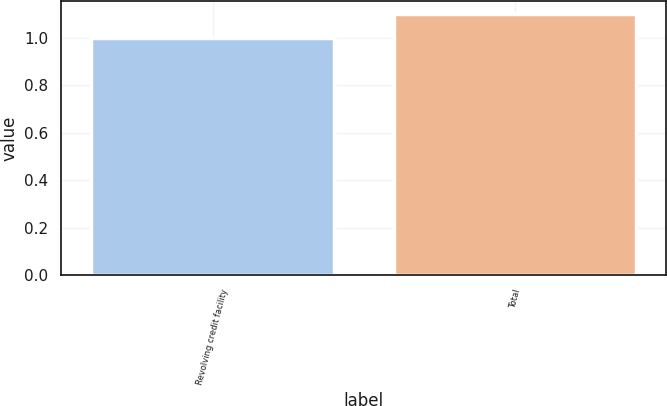Convert chart to OTSL. <chart><loc_0><loc_0><loc_500><loc_500><bar_chart><fcel>Revolving credit facility<fcel>Total<nl><fcel>1<fcel>1.1<nl></chart> 